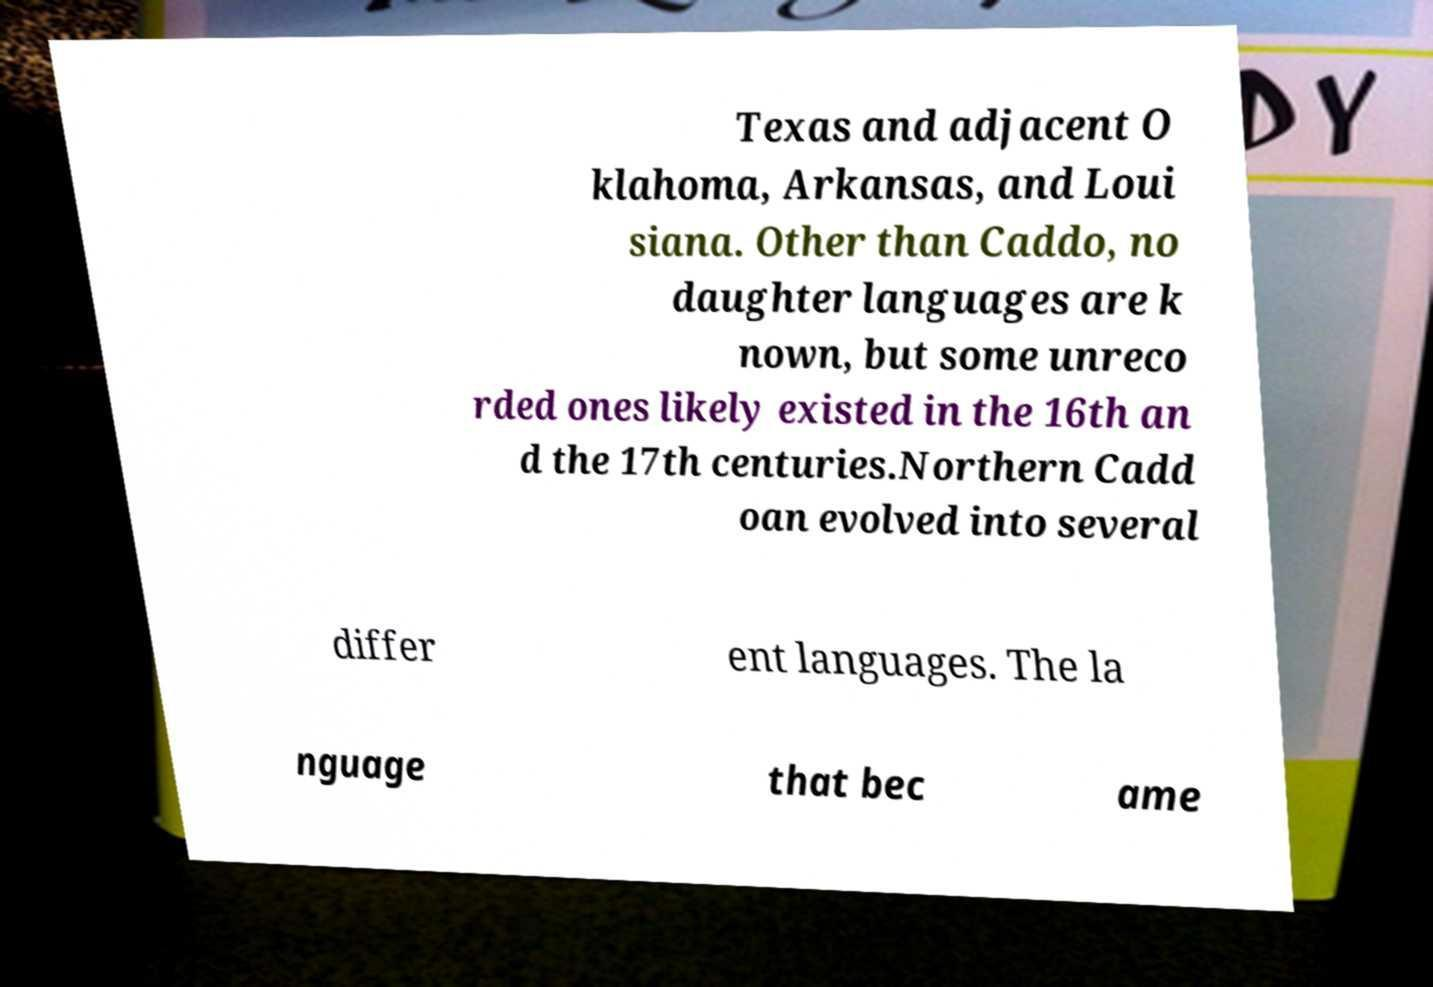Please read and relay the text visible in this image. What does it say? Texas and adjacent O klahoma, Arkansas, and Loui siana. Other than Caddo, no daughter languages are k nown, but some unreco rded ones likely existed in the 16th an d the 17th centuries.Northern Cadd oan evolved into several differ ent languages. The la nguage that bec ame 